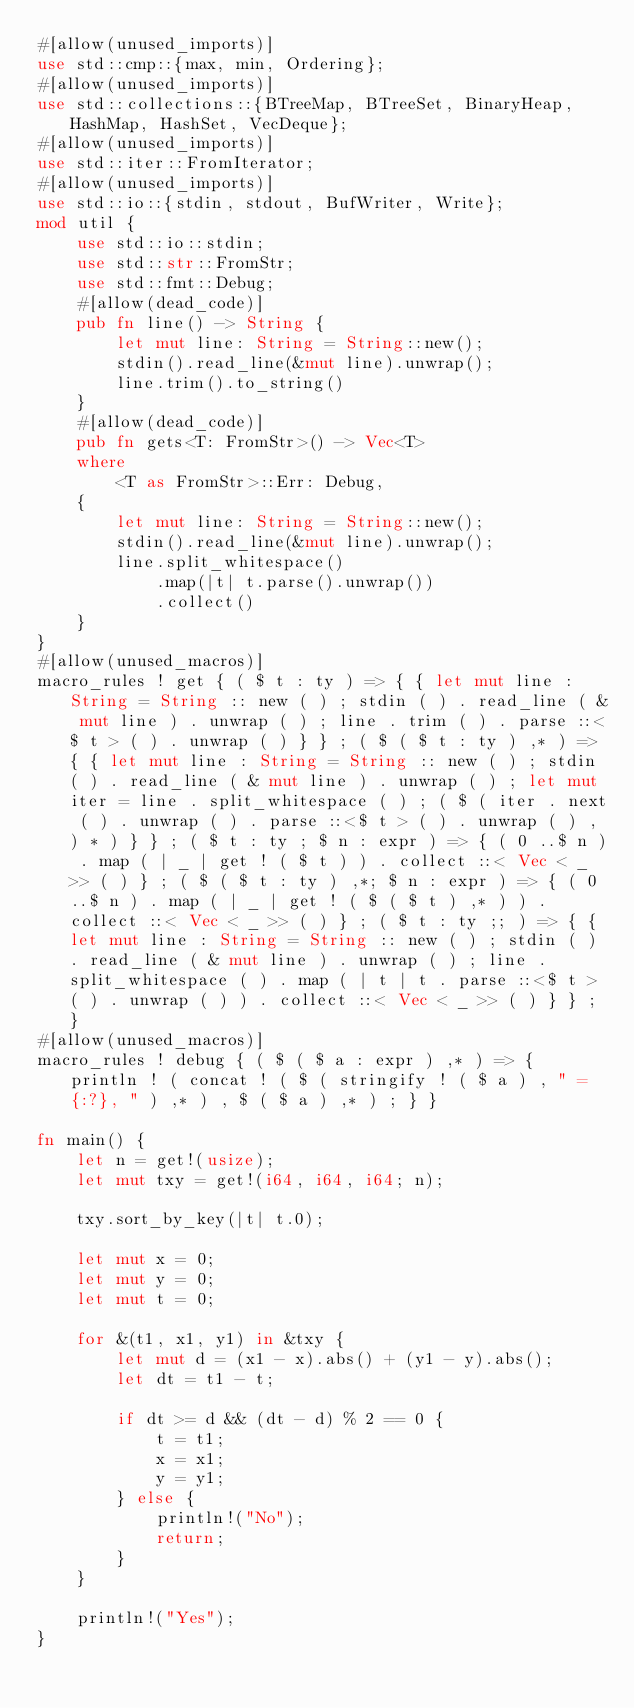<code> <loc_0><loc_0><loc_500><loc_500><_Rust_>#[allow(unused_imports)]
use std::cmp::{max, min, Ordering};
#[allow(unused_imports)]
use std::collections::{BTreeMap, BTreeSet, BinaryHeap, HashMap, HashSet, VecDeque};
#[allow(unused_imports)]
use std::iter::FromIterator;
#[allow(unused_imports)]
use std::io::{stdin, stdout, BufWriter, Write};
mod util {
    use std::io::stdin;
    use std::str::FromStr;
    use std::fmt::Debug;
    #[allow(dead_code)]
    pub fn line() -> String {
        let mut line: String = String::new();
        stdin().read_line(&mut line).unwrap();
        line.trim().to_string()
    }
    #[allow(dead_code)]
    pub fn gets<T: FromStr>() -> Vec<T>
    where
        <T as FromStr>::Err: Debug,
    {
        let mut line: String = String::new();
        stdin().read_line(&mut line).unwrap();
        line.split_whitespace()
            .map(|t| t.parse().unwrap())
            .collect()
    }
}
#[allow(unused_macros)]
macro_rules ! get { ( $ t : ty ) => { { let mut line : String = String :: new ( ) ; stdin ( ) . read_line ( & mut line ) . unwrap ( ) ; line . trim ( ) . parse ::<$ t > ( ) . unwrap ( ) } } ; ( $ ( $ t : ty ) ,* ) => { { let mut line : String = String :: new ( ) ; stdin ( ) . read_line ( & mut line ) . unwrap ( ) ; let mut iter = line . split_whitespace ( ) ; ( $ ( iter . next ( ) . unwrap ( ) . parse ::<$ t > ( ) . unwrap ( ) , ) * ) } } ; ( $ t : ty ; $ n : expr ) => { ( 0 ..$ n ) . map ( | _ | get ! ( $ t ) ) . collect ::< Vec < _ >> ( ) } ; ( $ ( $ t : ty ) ,*; $ n : expr ) => { ( 0 ..$ n ) . map ( | _ | get ! ( $ ( $ t ) ,* ) ) . collect ::< Vec < _ >> ( ) } ; ( $ t : ty ;; ) => { { let mut line : String = String :: new ( ) ; stdin ( ) . read_line ( & mut line ) . unwrap ( ) ; line . split_whitespace ( ) . map ( | t | t . parse ::<$ t > ( ) . unwrap ( ) ) . collect ::< Vec < _ >> ( ) } } ; }
#[allow(unused_macros)]
macro_rules ! debug { ( $ ( $ a : expr ) ,* ) => { println ! ( concat ! ( $ ( stringify ! ( $ a ) , " = {:?}, " ) ,* ) , $ ( $ a ) ,* ) ; } }

fn main() {
    let n = get!(usize);
    let mut txy = get!(i64, i64, i64; n);

    txy.sort_by_key(|t| t.0);

    let mut x = 0;
    let mut y = 0;
    let mut t = 0;

    for &(t1, x1, y1) in &txy {
        let mut d = (x1 - x).abs() + (y1 - y).abs();
        let dt = t1 - t;

        if dt >= d && (dt - d) % 2 == 0 {
            t = t1;
            x = x1;
            y = y1;
        } else {
            println!("No");
            return;
        }
    }

    println!("Yes");
}
</code> 